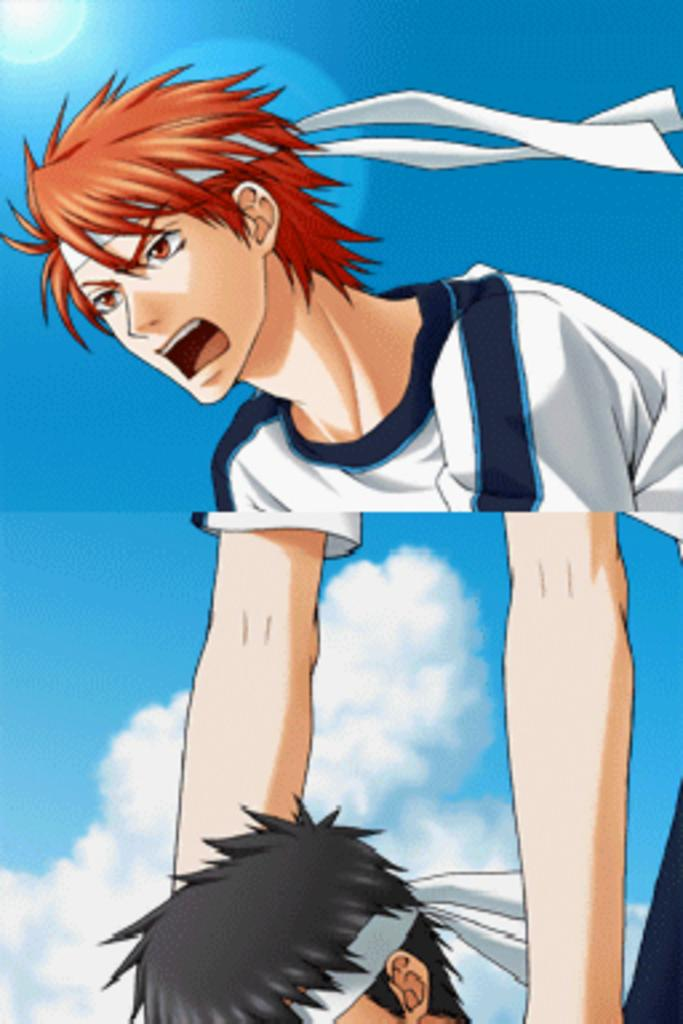What type of image is depicted in the picture? There is a cartoon picture of a person in the image. What can be seen in the background of the image? The sky is visible in the background of the image. What type of mountain is visible in the image? There is no mountain present in the image; it only features a cartoon picture of a person and the sky in the background. 